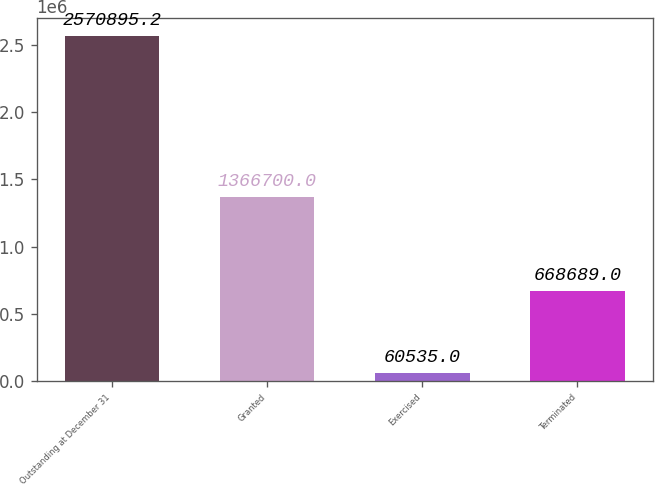Convert chart to OTSL. <chart><loc_0><loc_0><loc_500><loc_500><bar_chart><fcel>Outstanding at December 31<fcel>Granted<fcel>Exercised<fcel>Terminated<nl><fcel>2.5709e+06<fcel>1.3667e+06<fcel>60535<fcel>668689<nl></chart> 